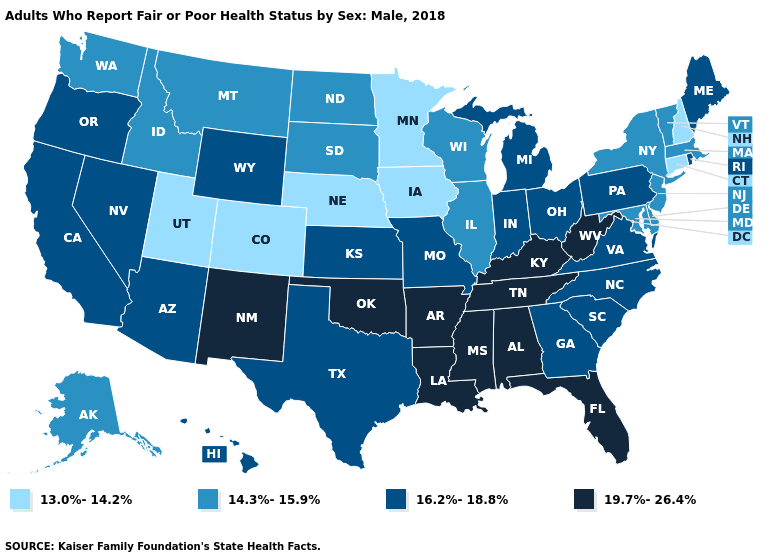What is the value of Rhode Island?
Give a very brief answer. 16.2%-18.8%. Does North Dakota have a lower value than Wisconsin?
Quick response, please. No. Name the states that have a value in the range 16.2%-18.8%?
Answer briefly. Arizona, California, Georgia, Hawaii, Indiana, Kansas, Maine, Michigan, Missouri, Nevada, North Carolina, Ohio, Oregon, Pennsylvania, Rhode Island, South Carolina, Texas, Virginia, Wyoming. Does Texas have a lower value than Kentucky?
Keep it brief. Yes. Does Ohio have the highest value in the MidWest?
Write a very short answer. Yes. Does South Carolina have the same value as Hawaii?
Give a very brief answer. Yes. What is the value of North Dakota?
Concise answer only. 14.3%-15.9%. Does the first symbol in the legend represent the smallest category?
Write a very short answer. Yes. What is the lowest value in the MidWest?
Write a very short answer. 13.0%-14.2%. Name the states that have a value in the range 13.0%-14.2%?
Keep it brief. Colorado, Connecticut, Iowa, Minnesota, Nebraska, New Hampshire, Utah. Does Vermont have the same value as South Dakota?
Give a very brief answer. Yes. Name the states that have a value in the range 13.0%-14.2%?
Concise answer only. Colorado, Connecticut, Iowa, Minnesota, Nebraska, New Hampshire, Utah. Name the states that have a value in the range 16.2%-18.8%?
Keep it brief. Arizona, California, Georgia, Hawaii, Indiana, Kansas, Maine, Michigan, Missouri, Nevada, North Carolina, Ohio, Oregon, Pennsylvania, Rhode Island, South Carolina, Texas, Virginia, Wyoming. Name the states that have a value in the range 14.3%-15.9%?
Short answer required. Alaska, Delaware, Idaho, Illinois, Maryland, Massachusetts, Montana, New Jersey, New York, North Dakota, South Dakota, Vermont, Washington, Wisconsin. Which states hav the highest value in the West?
Be succinct. New Mexico. 